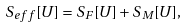<formula> <loc_0><loc_0><loc_500><loc_500>S _ { e f f } [ U ] = S _ { F } [ U ] + S _ { M } [ U ] ,</formula> 